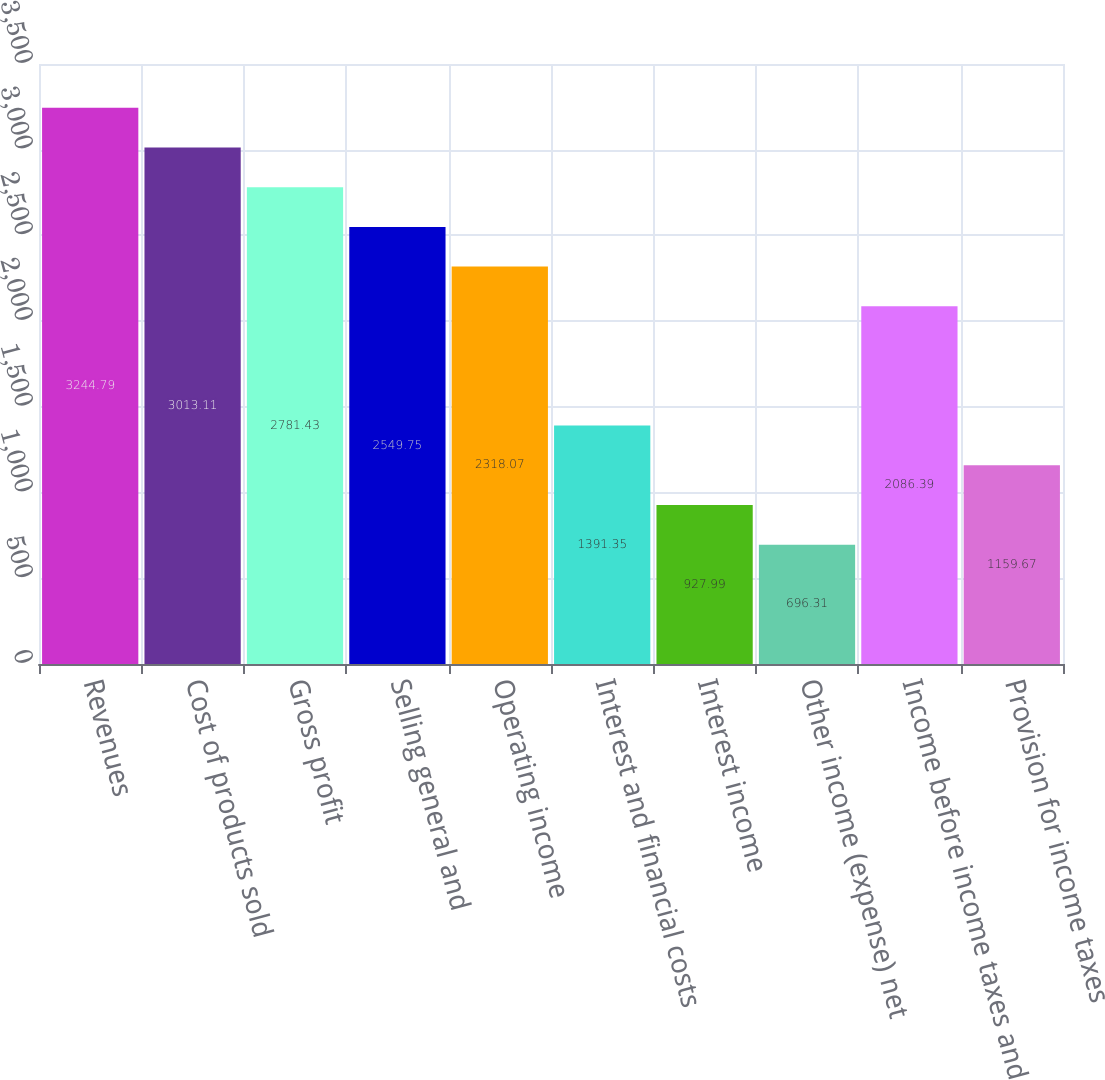Convert chart. <chart><loc_0><loc_0><loc_500><loc_500><bar_chart><fcel>Revenues<fcel>Cost of products sold<fcel>Gross profit<fcel>Selling general and<fcel>Operating income<fcel>Interest and financial costs<fcel>Interest income<fcel>Other income (expense) net<fcel>Income before income taxes and<fcel>Provision for income taxes<nl><fcel>3244.79<fcel>3013.11<fcel>2781.43<fcel>2549.75<fcel>2318.07<fcel>1391.35<fcel>927.99<fcel>696.31<fcel>2086.39<fcel>1159.67<nl></chart> 